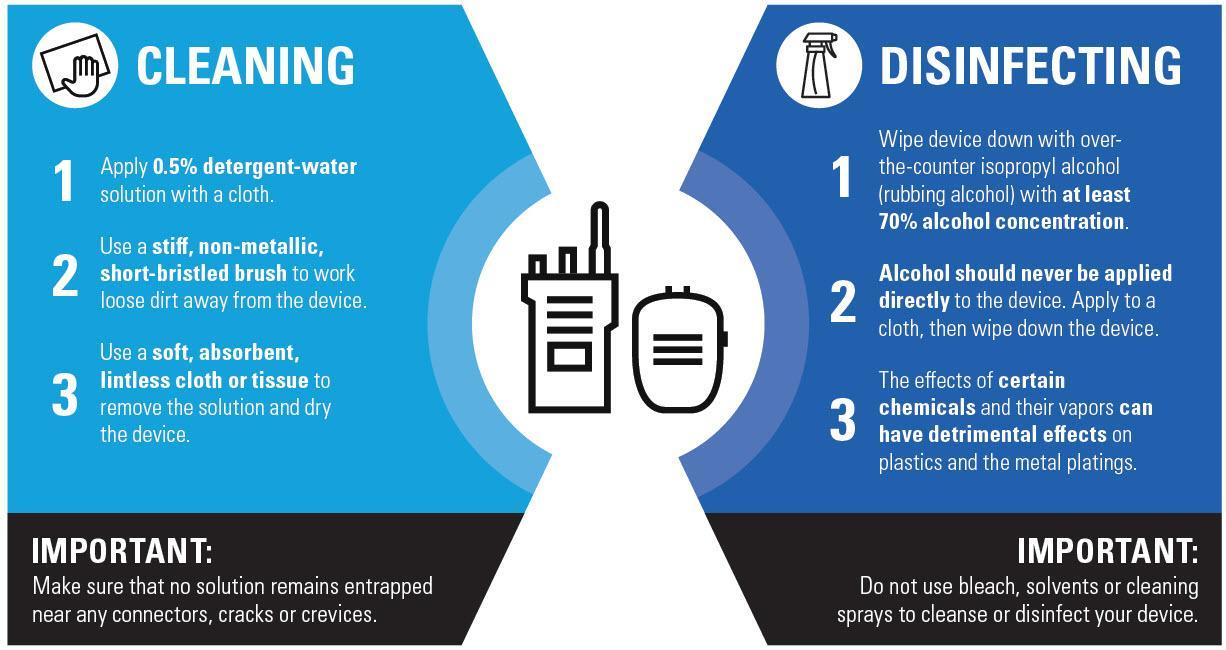Identify some key points in this picture. Isopropyl alcohol is commonly referred to as rubbing alcohol. The cloth used to remove the solution should be soft, absorbent, and lint-free to effectively clean the surface without leaving any residue. The appropriate solution for cleaning should consist of 0.5% detergent in water. It is recommended to use a stiff, non-metallic, short-bristled brush for cleaning purposes. It is recommended to use a clean, lint-free cloth or tissue to remove the solution and dry the device. 